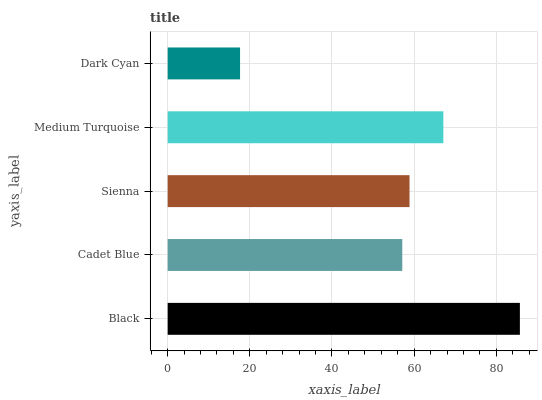Is Dark Cyan the minimum?
Answer yes or no. Yes. Is Black the maximum?
Answer yes or no. Yes. Is Cadet Blue the minimum?
Answer yes or no. No. Is Cadet Blue the maximum?
Answer yes or no. No. Is Black greater than Cadet Blue?
Answer yes or no. Yes. Is Cadet Blue less than Black?
Answer yes or no. Yes. Is Cadet Blue greater than Black?
Answer yes or no. No. Is Black less than Cadet Blue?
Answer yes or no. No. Is Sienna the high median?
Answer yes or no. Yes. Is Sienna the low median?
Answer yes or no. Yes. Is Medium Turquoise the high median?
Answer yes or no. No. Is Black the low median?
Answer yes or no. No. 